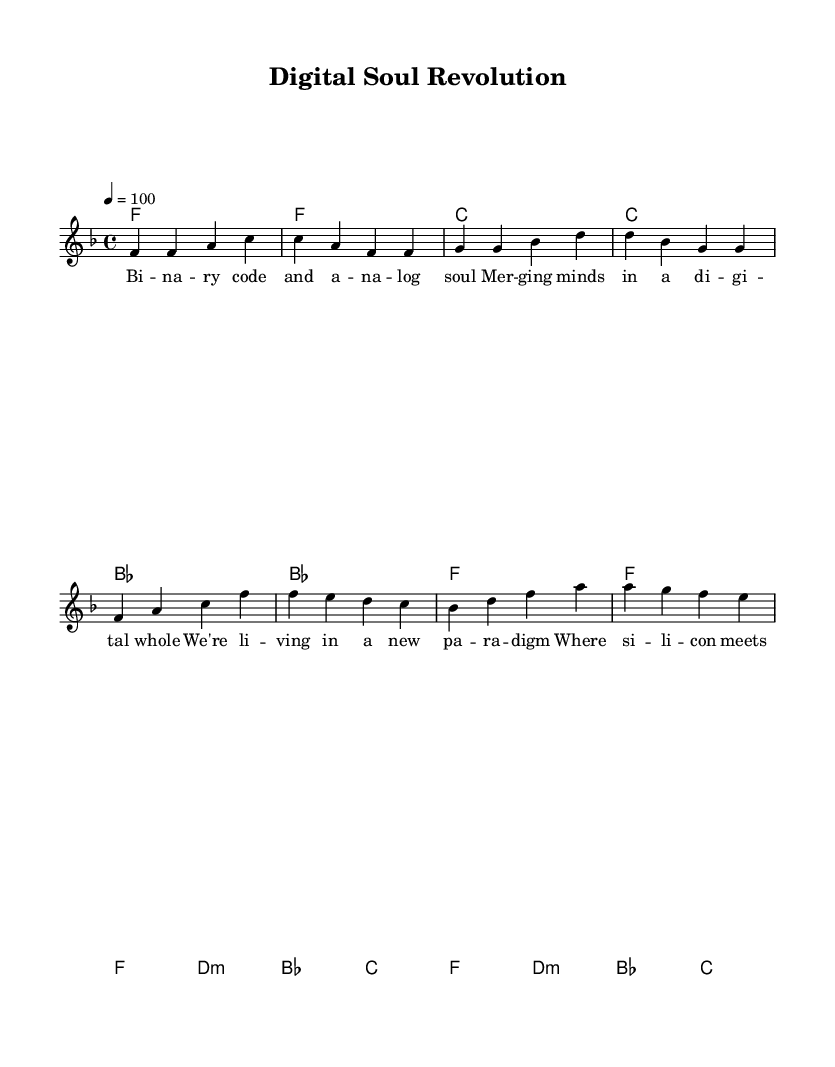What is the key signature of this music? The key signature indicated at the beginning of the score shows one flat, which corresponds to the key of F major.
Answer: F major What is the time signature of the piece? The time signature displayed at the beginning of the score is 4/4, meaning there are four beats per measure.
Answer: 4/4 What is the tempo marking for this piece? The tempo marking specifies a quarter note equals 100 beats per minute, indicating a moderate pace for the piece.
Answer: 100 How many measures are in the chorus section? Counting the measures in the chorus section from the score, there are a total of four measures.
Answer: 4 What are the first two notes of the melody? The melody begins with the notes F and F, as indicated in the score's first measure.
Answer: F, F What is the structure of the piece in terms of sections? The structure can be identified by the presence of verse and chorus sections, which follow a typical layout for a song.
Answer: Verse, Chorus What themes are reflected in the lyrics of the song? The lyrics discuss emerging digital realities and the blending of technology and the human experience, highlighting societal change.
Answer: Technological progress and societal change 